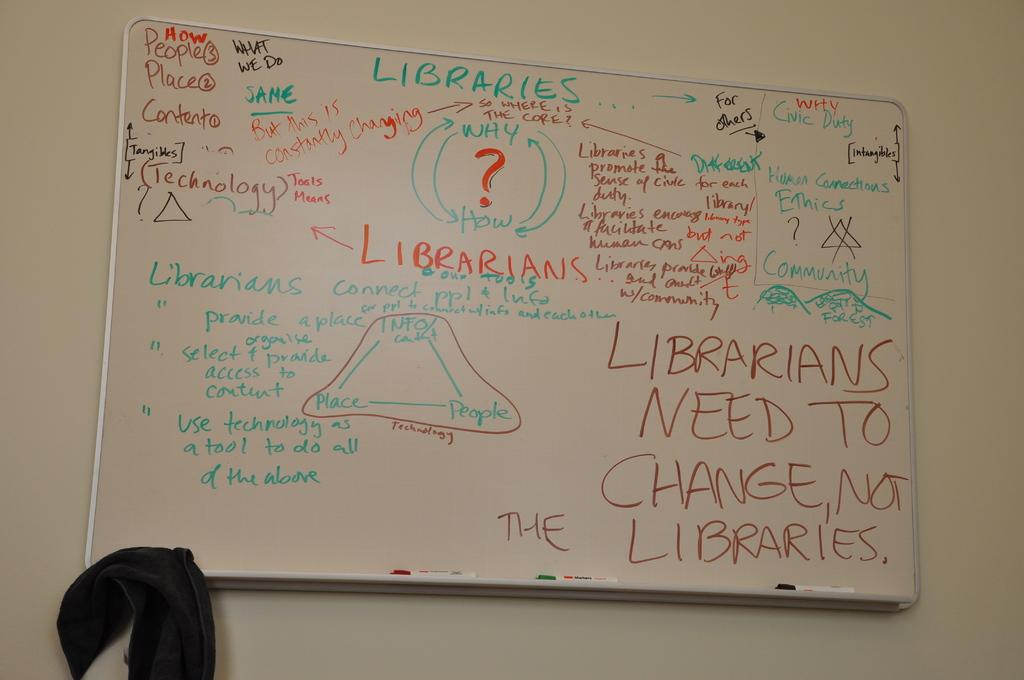<image>
Present a compact description of the photo's key features. A white board with a lot of writing, mostly saying library jargon 